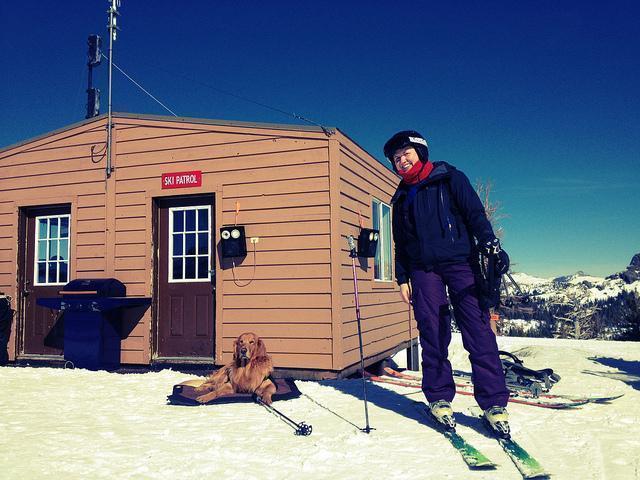What type of sign is on the building?
Choose the right answer from the provided options to respond to the question.
Options: Directional, informational, brand, warning. Informational. 